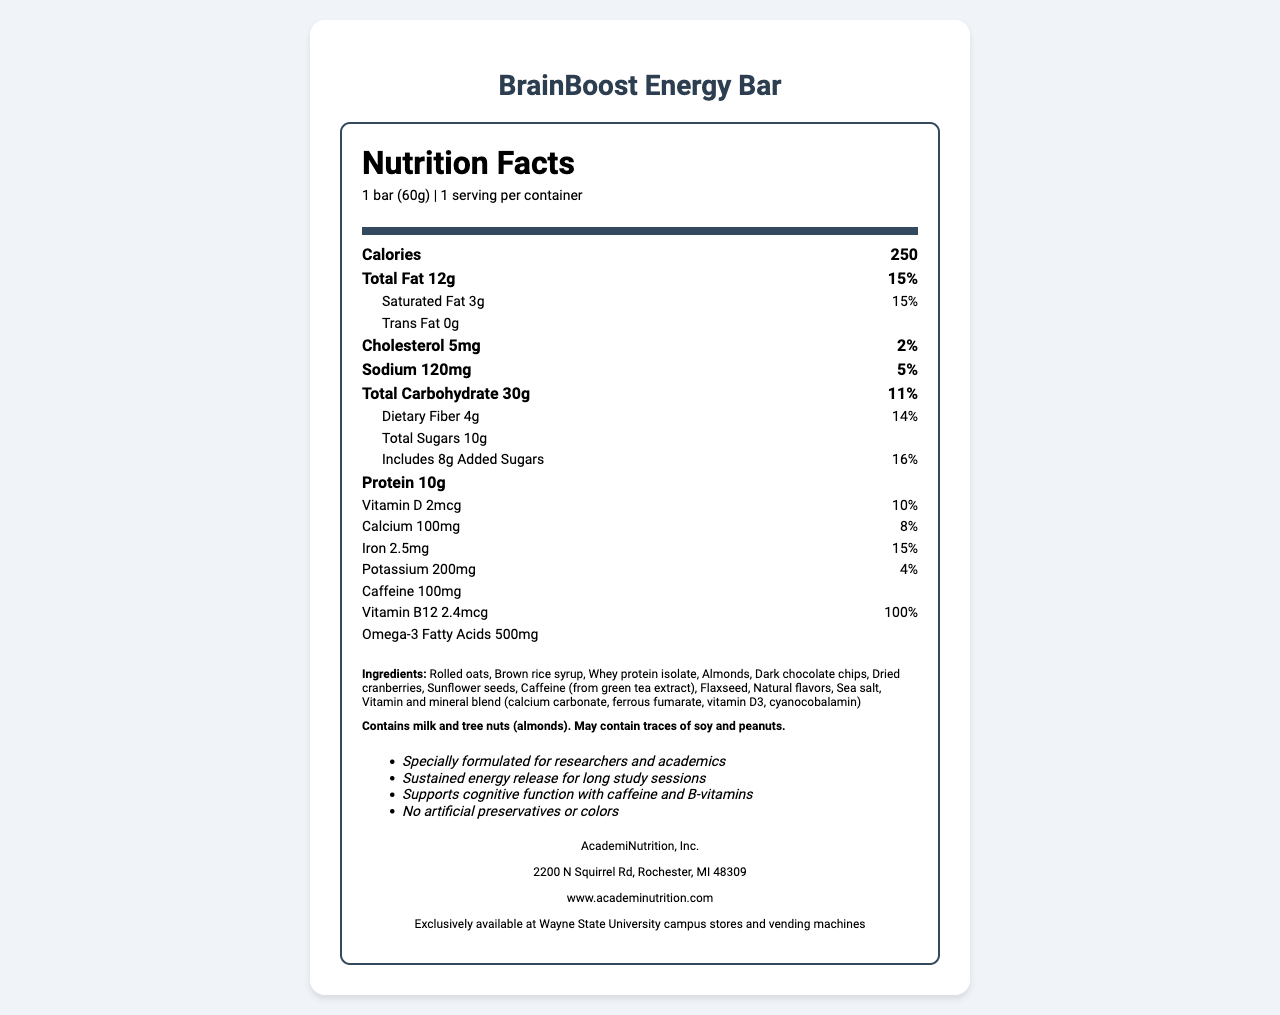what is the serving size for the BrainBoost Energy Bar? The document states that the serving size is 1 bar, equivalent to 60 grams.
Answer: 1 bar (60g) how many calories are in one serving of the BrainBoost Energy Bar? The document lists the calories per serving as 250.
Answer: 250 how much saturated fat is in the BrainBoost Energy Bar? The nutrition label indicates that there are 3 grams of saturated fat in one serving.
Answer: 3g does the BrainBoost Energy Bar contain any trans fat? The nutrition label shows that the trans fat content is 0g.
Answer: No what is the main ingredient in the BrainBoost Energy Bar? The ingredients list in the document starts with "Rolled oats."
Answer: Rolled oats how much cholesterol is in one bar? The document notes that the cholesterol content is 5mg per serving.
Answer: 5mg which allergen information is mentioned? A. Contains gluten B. Contains dairy and tree nuts C. Contains caffeine and gluten D. Contains no allergens The allergen info specifically mentions that it "Contains milk and tree nuts (almonds)."
Answer: B what is the source of caffeine in the BrainBoost Energy Bar? The ingredients list identifies "Caffeine (from green tea extract)" as the caffeine source.
Answer: Green tea extract how much protein does each BrainBoost Energy Bar contain? The nutrition label states that there are 10 grams of protein per serving.
Answer: 10g which vitamin has the highest % Daily Value in the BrainBoost Energy Bar? A. Vitamin D B. Calcium C. Iron D. Vitamin B12 The document shows that Vitamin B12 has a % Daily Value of 100%, which is the highest listed.
Answer: D is this product available at general grocery stores? The document states that the product is "Exclusively available at Wayne State University campus stores and vending machines."
Answer: No briefly summarize the main claims made about the BrainBoost Energy Bar. The claims listed in the document include benefits like sustained energy release, cognitive support, and no artificial preservatives or colors, emphasizing the bar’s suitability for researchers and academics.
Answer: The BrainBoost Energy Bar is specially formulated for researchers and academics, offers sustained energy release for long study sessions, supports cognitive function, and contains no artificial preservatives or colors. how much sodium is in each serving? The document lists the sodium content as 120mg per serving.
Answer: 120mg what is the quantity of added sugars in the BrainBoost Energy Bar? The nutrition facts label indicates that there are 8 grams of added sugars per serving.
Answer: 8g does the BrainBoost Energy Bar provide a significant source of dietary fiber? The document states that the bar contains 4g of dietary fiber, which is 14% of the Daily Value.
Answer: Yes which nutrient is not listed in the BrainBoost Energy Bar? A. Vitamin C B. Vitamin D C. Iron D. Potassium The document does not list Vitamin C among the nutrients, whereas Vitamin D, Iron, and Potassium are listed.
Answer: A what is the name of the manufacturer of the BrainBoost Energy Bar? The document provides the manufacturer's name as AcademiNutrition, Inc.
Answer: AcademiNutrition, Inc. how do the serving size and calories relate for the BrainBoost Energy Bar? The document specifies that each serving size is one bar, which weighs 60 grams and contains 250 calories.
Answer: The serving size is 1 bar (60g) and it contains 250 calories. where is AcademiNutrition, Inc. located? The manufacturer info provides the address as 2200 N Squirrel Rd, Rochester, MI 48309.
Answer: 2200 N Squirrel Rd, Rochester, MI 48309 how much caffeine is in one bar of the BrainBoost Energy Bar? The document lists the caffeine content as 100mg per serving.
Answer: 100mg why is the BrainBoost Energy Bar particularly suitable for researchers and academics? The claims emphasize that the bar provides sustained energy, cognitive support, and essential nutrients, making it ideal for the demanding schedules of researchers and academics.
Answer: Because it is specially formulated for sustained energy release, supports cognitive function, and contains nutrients important for long study sessions. what is the amount of iron in a serving? The document lists the iron content as 2.5mg per serving.
Answer: 2.5mg will you find artificial preservatives or colors in the BrainBoost Energy Bar? The claims explicitly state that there are no artificial preservatives or colors in the product.
Answer: No 